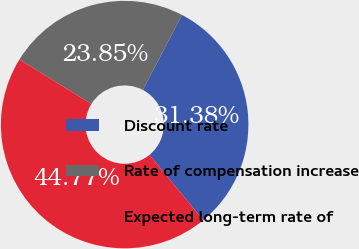Convert chart to OTSL. <chart><loc_0><loc_0><loc_500><loc_500><pie_chart><fcel>Discount rate<fcel>Rate of compensation increase<fcel>Expected long-term rate of<nl><fcel>31.38%<fcel>23.85%<fcel>44.77%<nl></chart> 